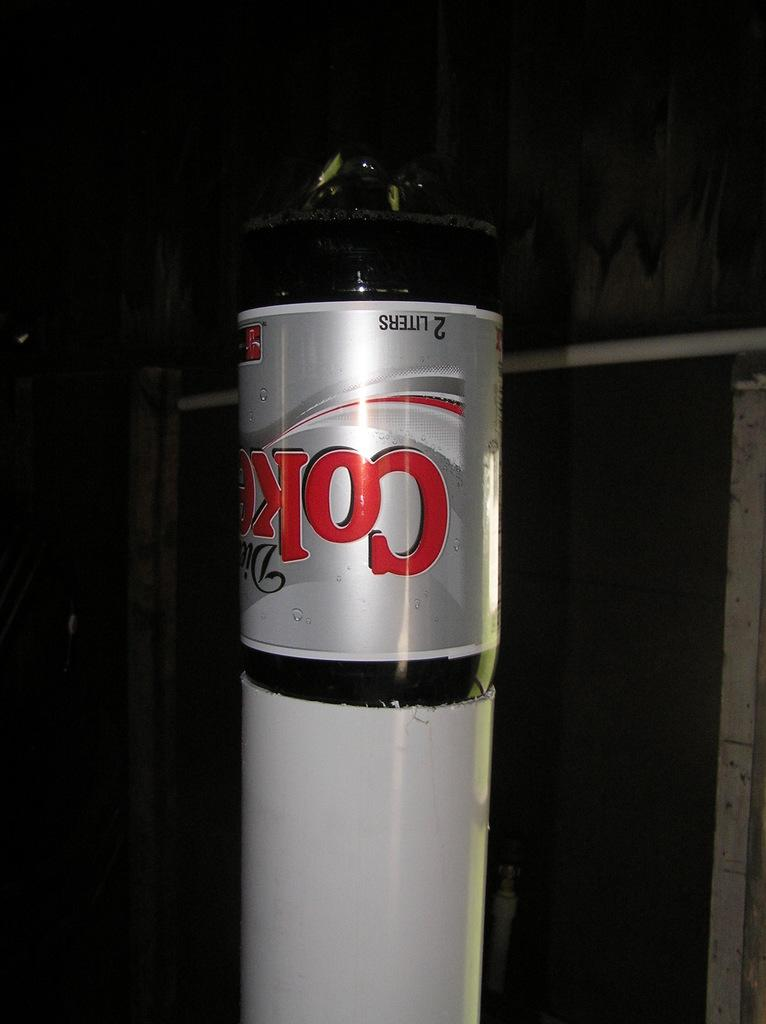Provide a one-sentence caption for the provided image. 2 Liter Diet Coke bottle set upside down in side of a large cut off section of PVC pipe which fits up to 1/5 of the way down the bottle. 